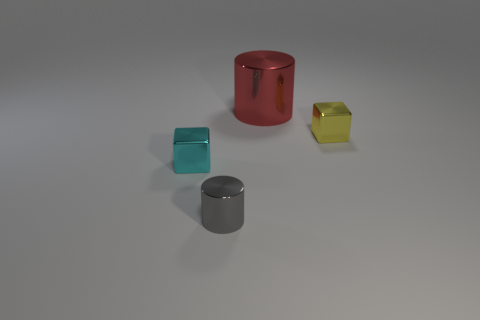Add 4 gray rubber cubes. How many objects exist? 8 Add 2 small yellow cubes. How many small yellow cubes exist? 3 Subtract 0 yellow spheres. How many objects are left? 4 Subtract all large brown metallic objects. Subtract all tiny cyan shiny objects. How many objects are left? 3 Add 4 tiny cyan shiny things. How many tiny cyan shiny things are left? 5 